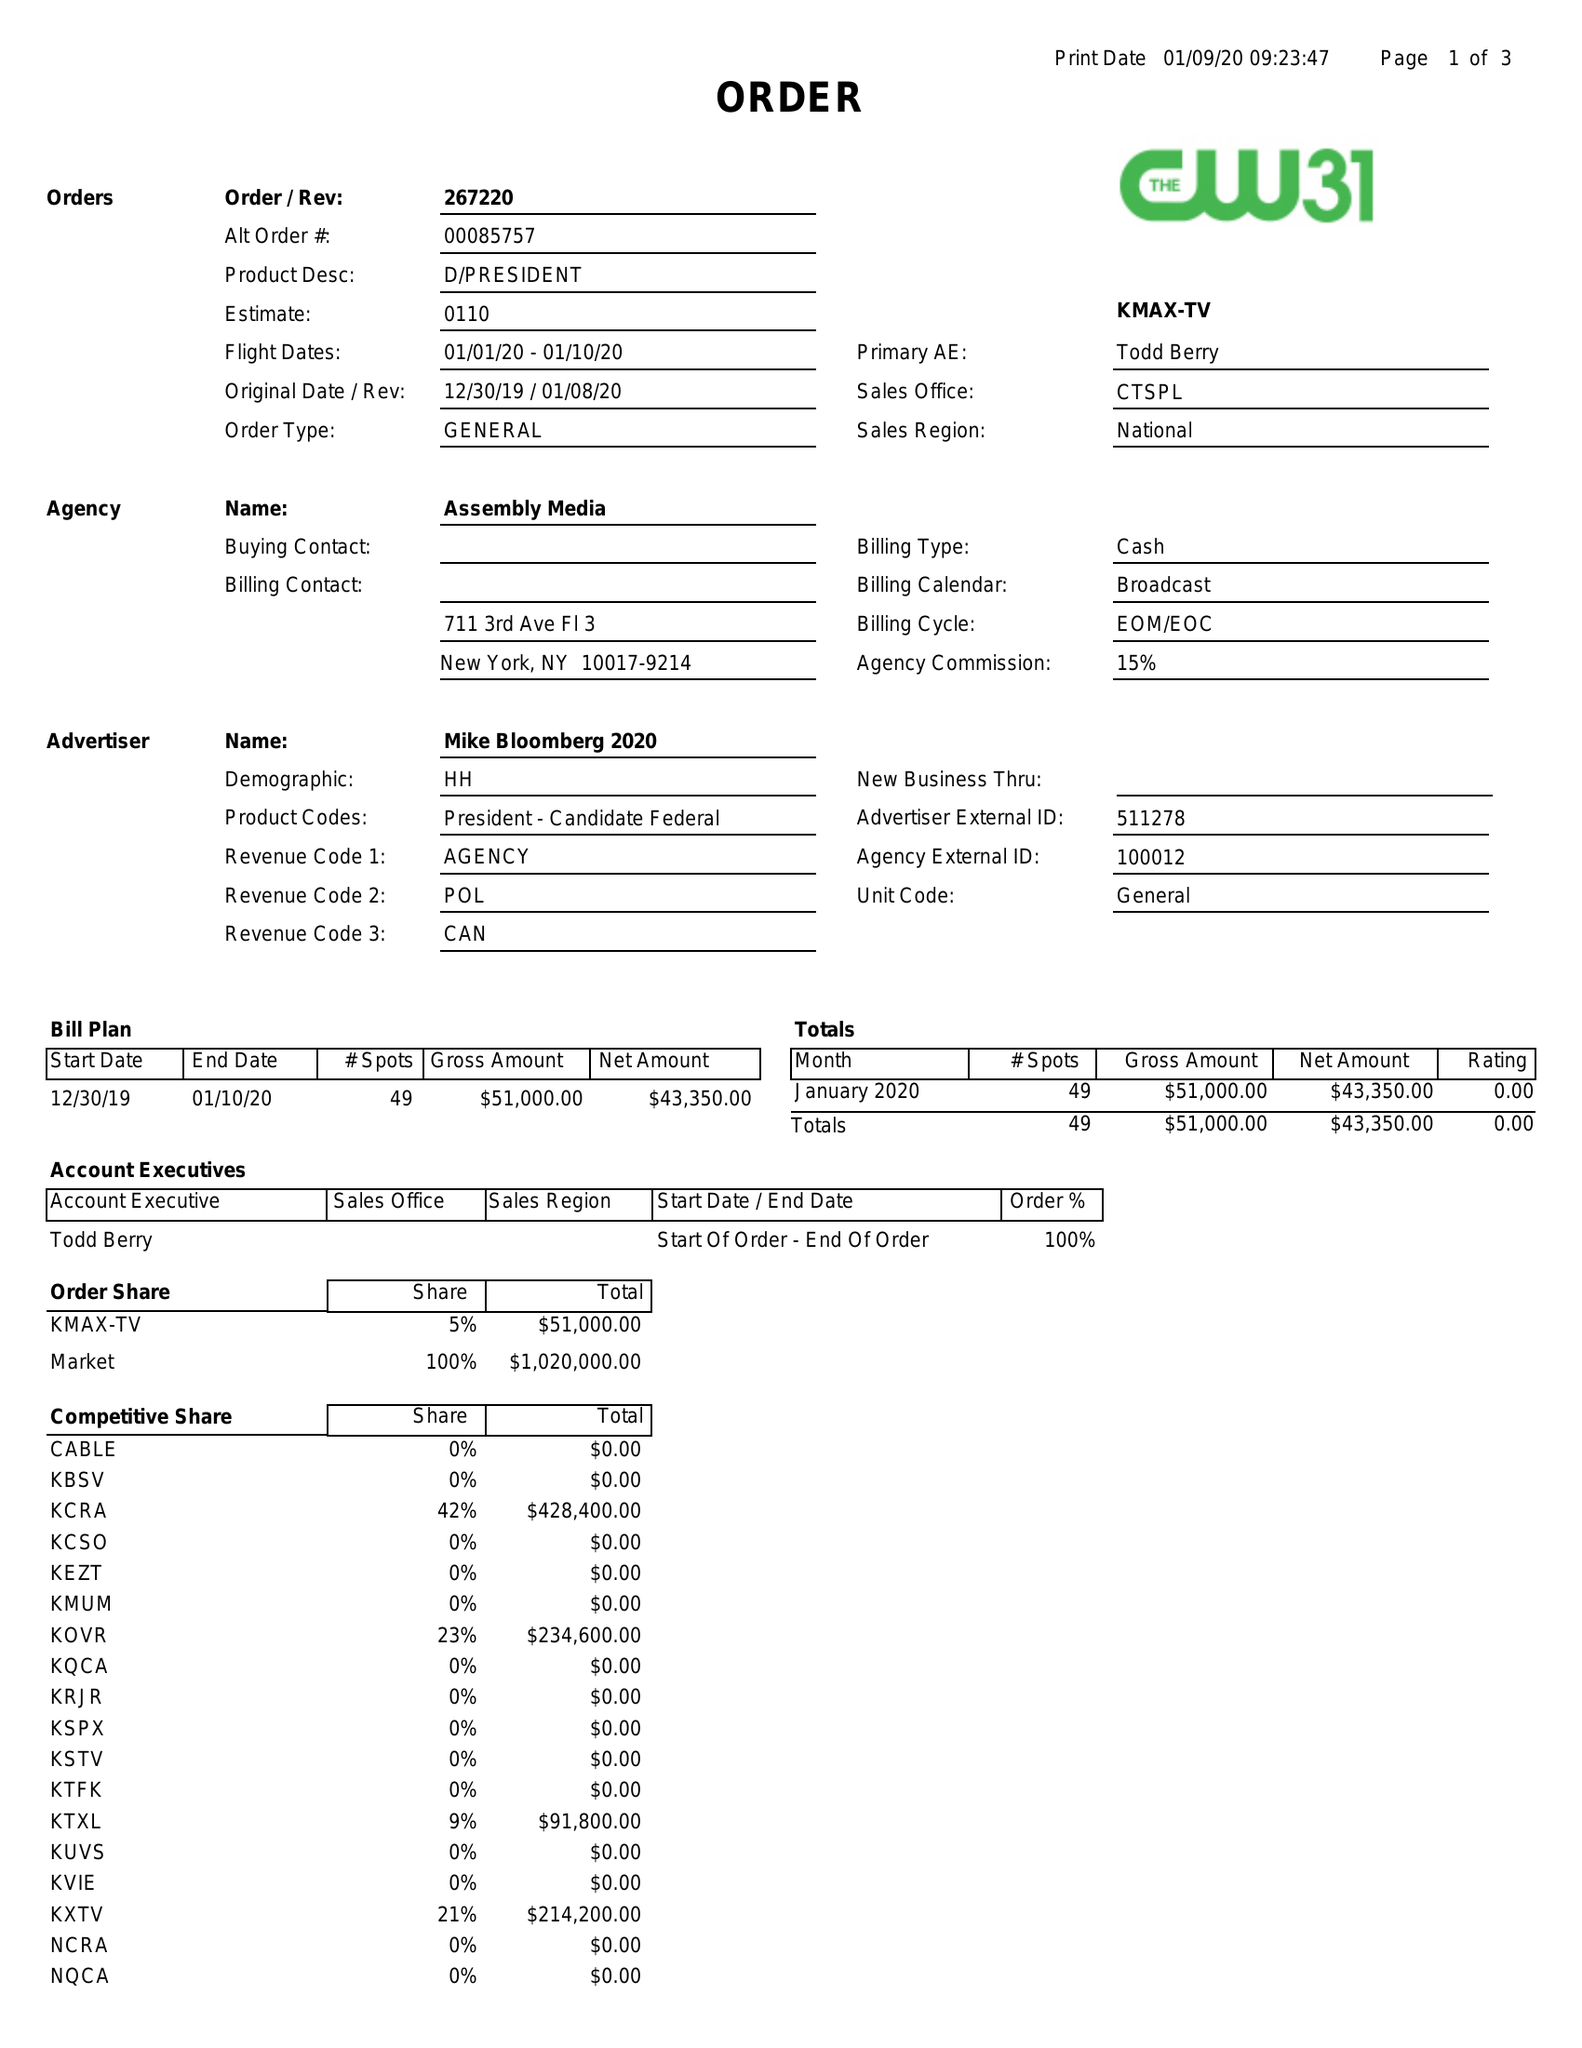What is the value for the contract_num?
Answer the question using a single word or phrase. 267220 